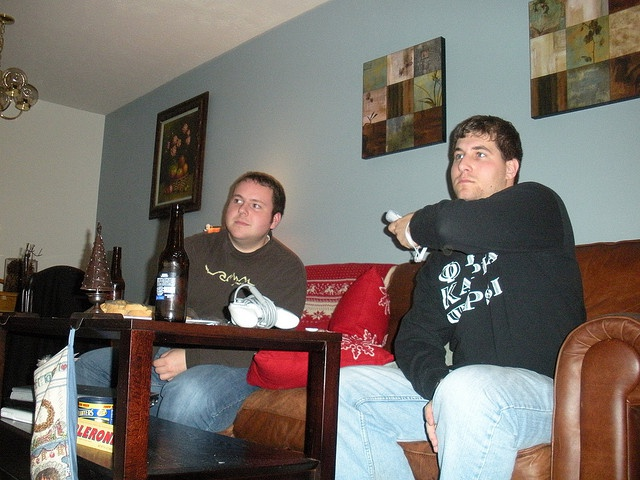Describe the objects in this image and their specific colors. I can see people in gray, black, lightblue, and purple tones, couch in gray, maroon, and brown tones, people in gray and black tones, bottle in gray, black, and white tones, and remote in gray, white, darkgray, and black tones in this image. 